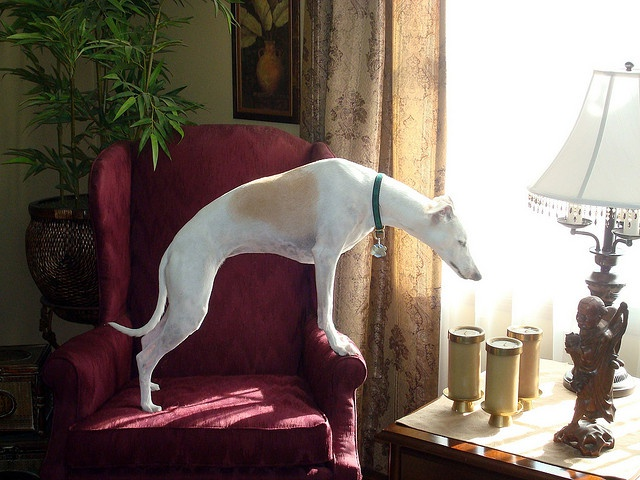Describe the objects in this image and their specific colors. I can see chair in black, maroon, brown, and lightpink tones, potted plant in black and darkgreen tones, dog in black, darkgray, ivory, and gray tones, vase in black, maroon, gray, and white tones, and vase in black and gray tones in this image. 